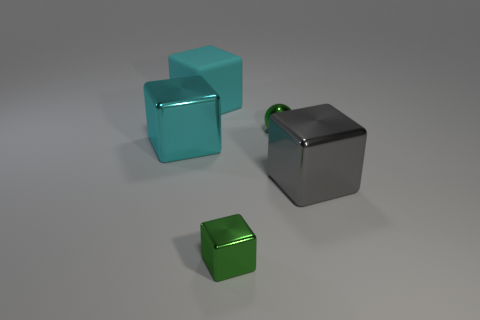What is the size of the green block that is the same material as the gray thing?
Offer a terse response. Small. Are there fewer large cyan shiny objects than gray matte cylinders?
Ensure brevity in your answer.  No. The cyan thing that is behind the cyan object that is in front of the green metal thing right of the tiny metal cube is made of what material?
Your response must be concise. Rubber. Are the cyan object that is left of the large matte thing and the big block that is on the right side of the large cyan matte cube made of the same material?
Provide a succinct answer. Yes. What size is the object that is behind the big cyan shiny cube and in front of the large cyan rubber object?
Your response must be concise. Small. What is the material of the green thing that is the same size as the green metal block?
Your answer should be compact. Metal. There is a block behind the shiny thing behind the cyan metal object; what number of blocks are in front of it?
Your response must be concise. 3. There is a big metallic block behind the big gray block; does it have the same color as the object that is behind the tiny green shiny sphere?
Provide a short and direct response. Yes. The object that is behind the cyan metallic block and on the right side of the green block is what color?
Give a very brief answer. Green. How many other shiny balls have the same size as the metallic ball?
Your response must be concise. 0. 